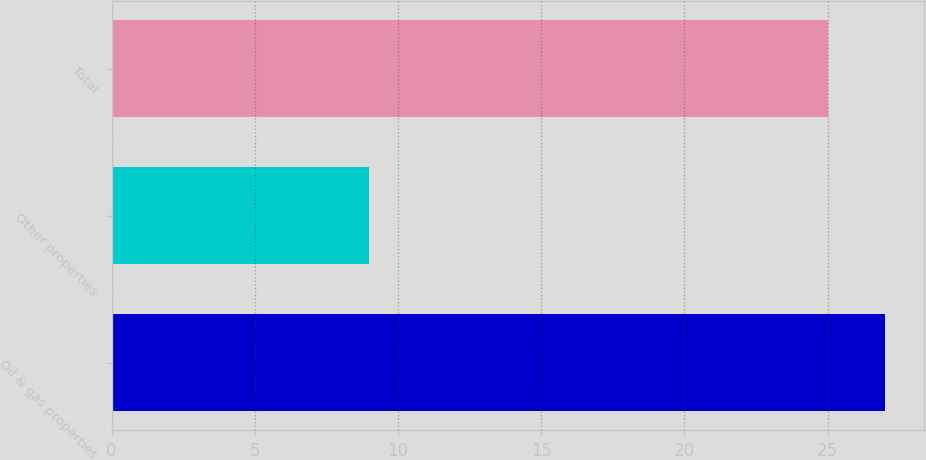Convert chart to OTSL. <chart><loc_0><loc_0><loc_500><loc_500><bar_chart><fcel>Oil & gas properties<fcel>Other properties<fcel>Total<nl><fcel>27<fcel>9<fcel>25<nl></chart> 